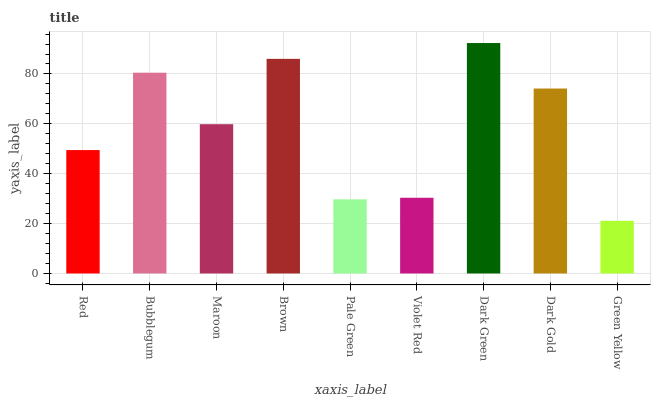Is Green Yellow the minimum?
Answer yes or no. Yes. Is Dark Green the maximum?
Answer yes or no. Yes. Is Bubblegum the minimum?
Answer yes or no. No. Is Bubblegum the maximum?
Answer yes or no. No. Is Bubblegum greater than Red?
Answer yes or no. Yes. Is Red less than Bubblegum?
Answer yes or no. Yes. Is Red greater than Bubblegum?
Answer yes or no. No. Is Bubblegum less than Red?
Answer yes or no. No. Is Maroon the high median?
Answer yes or no. Yes. Is Maroon the low median?
Answer yes or no. Yes. Is Brown the high median?
Answer yes or no. No. Is Pale Green the low median?
Answer yes or no. No. 